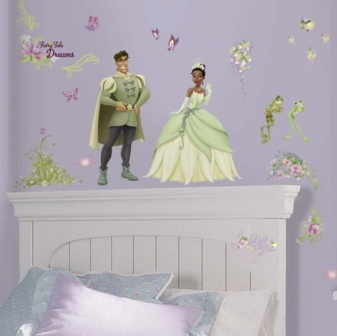Describe the following image. The image captures a whimsical bedroom scene. Prominently featured is a wall painted in a vibrant shade of lavender, adorned with an array of decorative stickers. At the focal point, just above a white headboard, are stickers of a prince and princess, elegantly dressed in green and engaged in an enchanting pose as if in mid-conversation, creating a playful atmosphere.

To the right, a frog sticker appears as if it is leaping onto the scene, contributing a touch of fairy-tale magic to the décor. Surrounding these characters are numerous butterflies and flowers, which seem to flutter around, adding a lively natural element to the setting.

Below this charming display is a bed with a purple comforter, corresponding to the wall color, and is further adorned with white pillows that provide a subtle contrast to the dominant hues. The entire scene exudes a dreamlike quality, blending elements of fantasy and comfort harmoniously. 